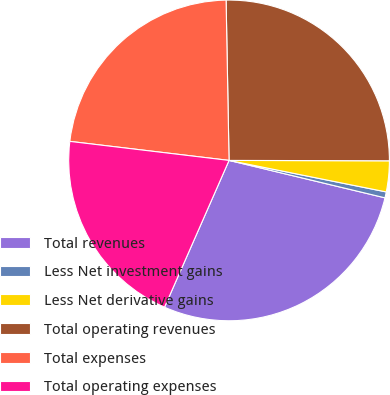<chart> <loc_0><loc_0><loc_500><loc_500><pie_chart><fcel>Total revenues<fcel>Less Net investment gains<fcel>Less Net derivative gains<fcel>Total operating revenues<fcel>Total expenses<fcel>Total operating expenses<nl><fcel>27.84%<fcel>0.6%<fcel>3.11%<fcel>25.33%<fcel>22.81%<fcel>20.3%<nl></chart> 